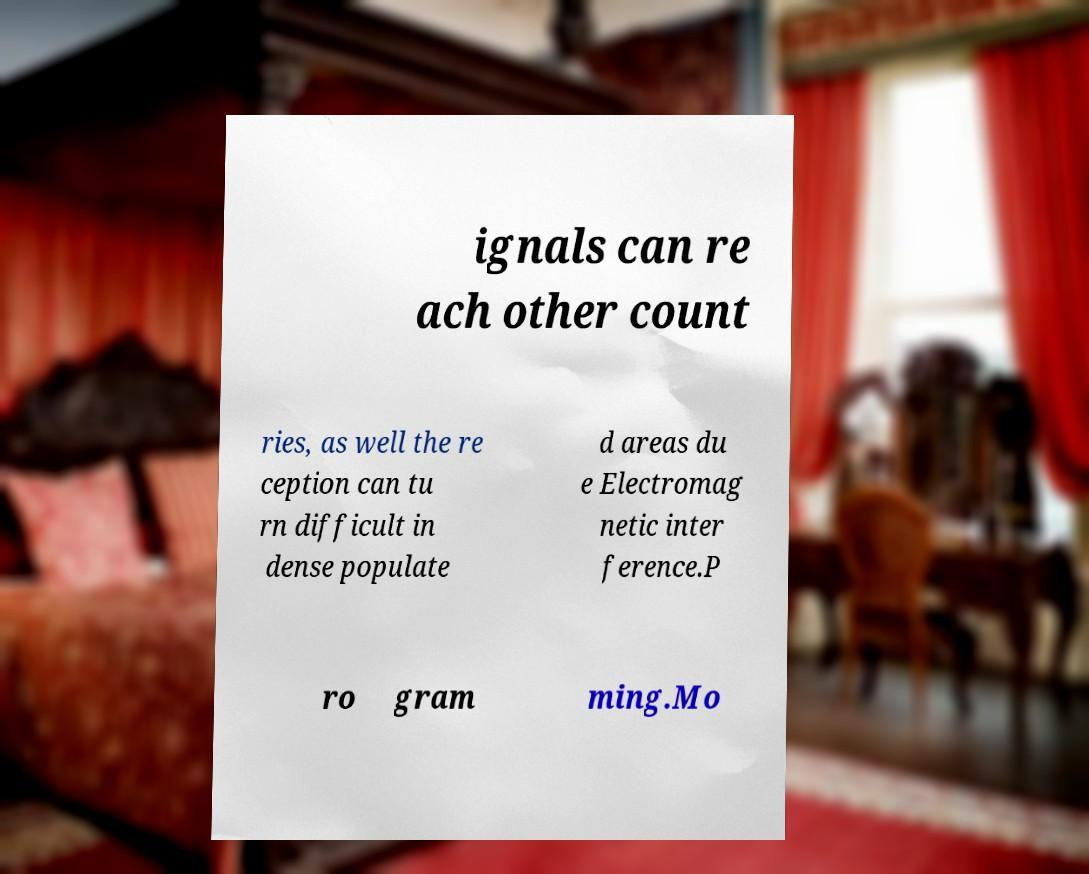Can you read and provide the text displayed in the image?This photo seems to have some interesting text. Can you extract and type it out for me? ignals can re ach other count ries, as well the re ception can tu rn difficult in dense populate d areas du e Electromag netic inter ference.P ro gram ming.Mo 